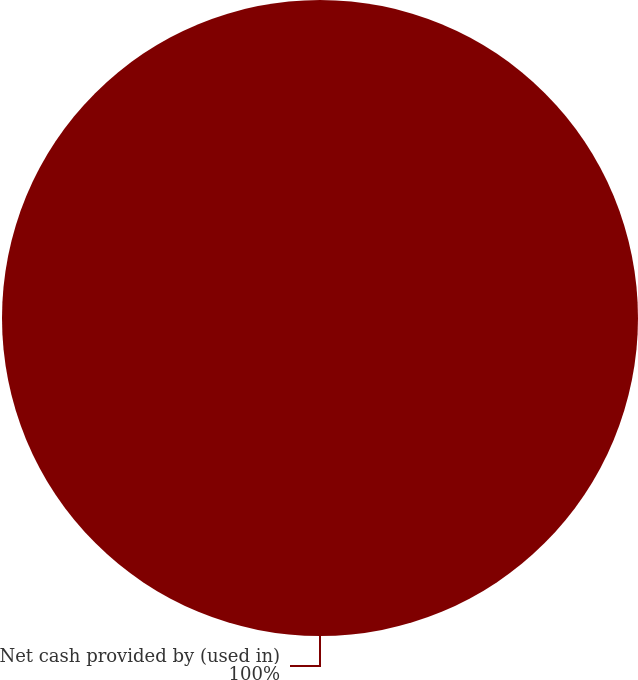<chart> <loc_0><loc_0><loc_500><loc_500><pie_chart><fcel>Net cash provided by (used in)<nl><fcel>100.0%<nl></chart> 